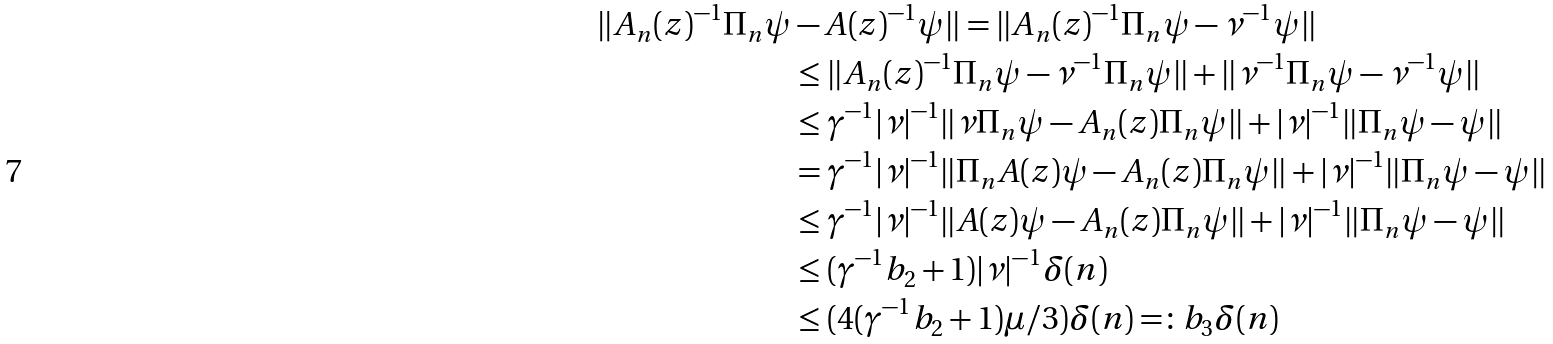<formula> <loc_0><loc_0><loc_500><loc_500>\| A _ { n } ( z ) ^ { - 1 } \Pi _ { n } \psi & - A ( z ) ^ { - 1 } \psi \| = \| A _ { n } ( z ) ^ { - 1 } \Pi _ { n } \psi - \nu ^ { - 1 } \psi \| \\ & \leq \| A _ { n } ( z ) ^ { - 1 } \Pi _ { n } \psi - \nu ^ { - 1 } \Pi _ { n } \psi \| + \| \nu ^ { - 1 } \Pi _ { n } \psi - \nu ^ { - 1 } \psi \| \\ & \leq \gamma ^ { - 1 } | \nu | ^ { - 1 } \| \nu \Pi _ { n } \psi - A _ { n } ( z ) \Pi _ { n } \psi \| + | \nu | ^ { - 1 } \| \Pi _ { n } \psi - \psi \| \\ & = \gamma ^ { - 1 } | \nu | ^ { - 1 } \| \Pi _ { n } A ( z ) \psi - A _ { n } ( z ) \Pi _ { n } \psi \| + | \nu | ^ { - 1 } \| \Pi _ { n } \psi - \psi \| \\ & \leq \gamma ^ { - 1 } | \nu | ^ { - 1 } \| A ( z ) \psi - A _ { n } ( z ) \Pi _ { n } \psi \| + | \nu | ^ { - 1 } \| \Pi _ { n } \psi - \psi \| \\ & \leq ( \gamma ^ { - 1 } b _ { 2 } + 1 ) | \nu | ^ { - 1 } \delta ( n ) \\ & \leq ( 4 ( \gamma ^ { - 1 } b _ { 2 } + 1 ) \mu / 3 ) \delta ( n ) = \colon b _ { 3 } \delta ( n )</formula> 